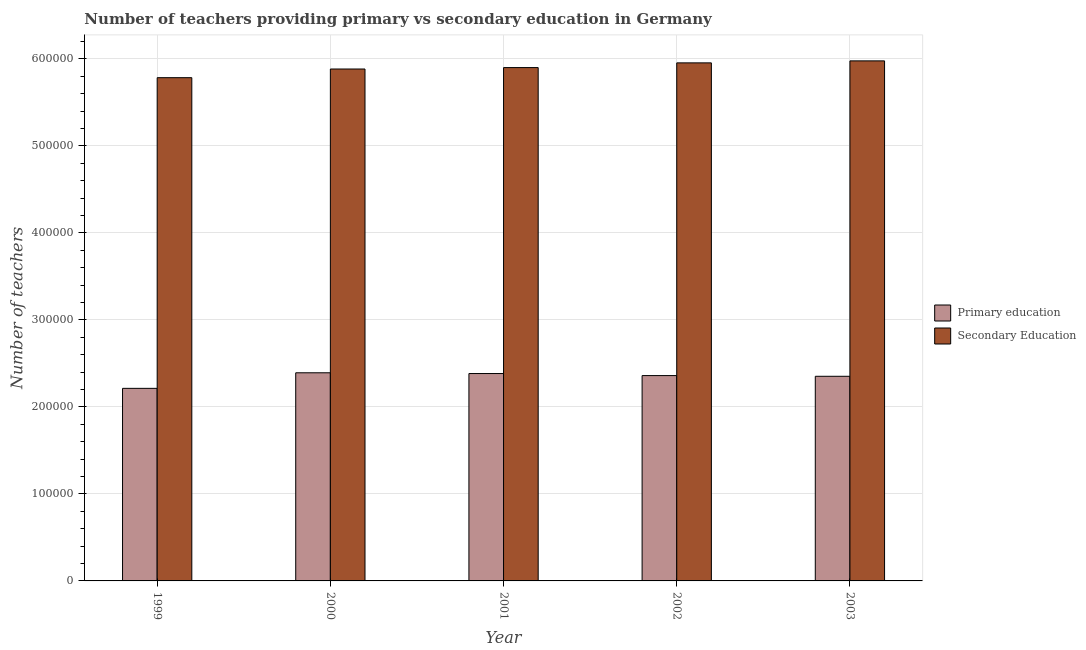How many different coloured bars are there?
Ensure brevity in your answer.  2. How many groups of bars are there?
Offer a very short reply. 5. In how many cases, is the number of bars for a given year not equal to the number of legend labels?
Make the answer very short. 0. What is the number of secondary teachers in 1999?
Make the answer very short. 5.78e+05. Across all years, what is the maximum number of primary teachers?
Ensure brevity in your answer.  2.39e+05. Across all years, what is the minimum number of secondary teachers?
Your answer should be very brief. 5.78e+05. In which year was the number of primary teachers maximum?
Ensure brevity in your answer.  2000. In which year was the number of secondary teachers minimum?
Provide a short and direct response. 1999. What is the total number of secondary teachers in the graph?
Provide a short and direct response. 2.95e+06. What is the difference between the number of secondary teachers in 1999 and that in 2001?
Provide a short and direct response. -1.16e+04. What is the difference between the number of secondary teachers in 1999 and the number of primary teachers in 2000?
Your response must be concise. -9953. What is the average number of secondary teachers per year?
Make the answer very short. 5.90e+05. In how many years, is the number of secondary teachers greater than 360000?
Keep it short and to the point. 5. What is the ratio of the number of primary teachers in 1999 to that in 2001?
Provide a succinct answer. 0.93. Is the number of primary teachers in 2000 less than that in 2001?
Provide a short and direct response. No. Is the difference between the number of secondary teachers in 1999 and 2000 greater than the difference between the number of primary teachers in 1999 and 2000?
Provide a short and direct response. No. What is the difference between the highest and the second highest number of secondary teachers?
Offer a very short reply. 2293. What is the difference between the highest and the lowest number of secondary teachers?
Your answer should be compact. 1.93e+04. Is the sum of the number of primary teachers in 1999 and 2002 greater than the maximum number of secondary teachers across all years?
Your response must be concise. Yes. What does the 2nd bar from the left in 2002 represents?
Your response must be concise. Secondary Education. How many bars are there?
Offer a very short reply. 10. How many years are there in the graph?
Make the answer very short. 5. What is the difference between two consecutive major ticks on the Y-axis?
Your response must be concise. 1.00e+05. Does the graph contain grids?
Ensure brevity in your answer.  Yes. Where does the legend appear in the graph?
Provide a succinct answer. Center right. How many legend labels are there?
Keep it short and to the point. 2. How are the legend labels stacked?
Make the answer very short. Vertical. What is the title of the graph?
Offer a terse response. Number of teachers providing primary vs secondary education in Germany. What is the label or title of the X-axis?
Your answer should be very brief. Year. What is the label or title of the Y-axis?
Your answer should be compact. Number of teachers. What is the Number of teachers in Primary education in 1999?
Your answer should be very brief. 2.21e+05. What is the Number of teachers in Secondary Education in 1999?
Ensure brevity in your answer.  5.78e+05. What is the Number of teachers of Primary education in 2000?
Ensure brevity in your answer.  2.39e+05. What is the Number of teachers of Secondary Education in 2000?
Offer a terse response. 5.88e+05. What is the Number of teachers in Primary education in 2001?
Your answer should be very brief. 2.38e+05. What is the Number of teachers of Secondary Education in 2001?
Ensure brevity in your answer.  5.90e+05. What is the Number of teachers in Primary education in 2002?
Offer a very short reply. 2.36e+05. What is the Number of teachers of Secondary Education in 2002?
Provide a short and direct response. 5.95e+05. What is the Number of teachers of Primary education in 2003?
Give a very brief answer. 2.35e+05. What is the Number of teachers of Secondary Education in 2003?
Ensure brevity in your answer.  5.98e+05. Across all years, what is the maximum Number of teachers of Primary education?
Offer a very short reply. 2.39e+05. Across all years, what is the maximum Number of teachers in Secondary Education?
Provide a succinct answer. 5.98e+05. Across all years, what is the minimum Number of teachers in Primary education?
Provide a succinct answer. 2.21e+05. Across all years, what is the minimum Number of teachers of Secondary Education?
Your answer should be very brief. 5.78e+05. What is the total Number of teachers of Primary education in the graph?
Provide a succinct answer. 1.17e+06. What is the total Number of teachers of Secondary Education in the graph?
Offer a very short reply. 2.95e+06. What is the difference between the Number of teachers of Primary education in 1999 and that in 2000?
Offer a terse response. -1.79e+04. What is the difference between the Number of teachers in Secondary Education in 1999 and that in 2000?
Your response must be concise. -9953. What is the difference between the Number of teachers of Primary education in 1999 and that in 2001?
Keep it short and to the point. -1.70e+04. What is the difference between the Number of teachers in Secondary Education in 1999 and that in 2001?
Offer a terse response. -1.16e+04. What is the difference between the Number of teachers of Primary education in 1999 and that in 2002?
Provide a succinct answer. -1.47e+04. What is the difference between the Number of teachers in Secondary Education in 1999 and that in 2002?
Keep it short and to the point. -1.70e+04. What is the difference between the Number of teachers in Primary education in 1999 and that in 2003?
Keep it short and to the point. -1.39e+04. What is the difference between the Number of teachers in Secondary Education in 1999 and that in 2003?
Provide a short and direct response. -1.93e+04. What is the difference between the Number of teachers in Primary education in 2000 and that in 2001?
Offer a terse response. 861. What is the difference between the Number of teachers of Secondary Education in 2000 and that in 2001?
Your response must be concise. -1636. What is the difference between the Number of teachers of Primary education in 2000 and that in 2002?
Provide a short and direct response. 3213. What is the difference between the Number of teachers of Secondary Education in 2000 and that in 2002?
Give a very brief answer. -7059. What is the difference between the Number of teachers in Primary education in 2000 and that in 2003?
Your response must be concise. 4027. What is the difference between the Number of teachers in Secondary Education in 2000 and that in 2003?
Provide a short and direct response. -9352. What is the difference between the Number of teachers of Primary education in 2001 and that in 2002?
Your answer should be compact. 2352. What is the difference between the Number of teachers of Secondary Education in 2001 and that in 2002?
Your answer should be very brief. -5423. What is the difference between the Number of teachers of Primary education in 2001 and that in 2003?
Your answer should be compact. 3166. What is the difference between the Number of teachers of Secondary Education in 2001 and that in 2003?
Provide a short and direct response. -7716. What is the difference between the Number of teachers of Primary education in 2002 and that in 2003?
Provide a succinct answer. 814. What is the difference between the Number of teachers in Secondary Education in 2002 and that in 2003?
Give a very brief answer. -2293. What is the difference between the Number of teachers of Primary education in 1999 and the Number of teachers of Secondary Education in 2000?
Keep it short and to the point. -3.67e+05. What is the difference between the Number of teachers of Primary education in 1999 and the Number of teachers of Secondary Education in 2001?
Provide a short and direct response. -3.69e+05. What is the difference between the Number of teachers of Primary education in 1999 and the Number of teachers of Secondary Education in 2002?
Your answer should be very brief. -3.74e+05. What is the difference between the Number of teachers of Primary education in 1999 and the Number of teachers of Secondary Education in 2003?
Provide a succinct answer. -3.76e+05. What is the difference between the Number of teachers in Primary education in 2000 and the Number of teachers in Secondary Education in 2001?
Provide a succinct answer. -3.51e+05. What is the difference between the Number of teachers in Primary education in 2000 and the Number of teachers in Secondary Education in 2002?
Provide a succinct answer. -3.56e+05. What is the difference between the Number of teachers of Primary education in 2000 and the Number of teachers of Secondary Education in 2003?
Keep it short and to the point. -3.58e+05. What is the difference between the Number of teachers in Primary education in 2001 and the Number of teachers in Secondary Education in 2002?
Provide a succinct answer. -3.57e+05. What is the difference between the Number of teachers of Primary education in 2001 and the Number of teachers of Secondary Education in 2003?
Offer a very short reply. -3.59e+05. What is the difference between the Number of teachers of Primary education in 2002 and the Number of teachers of Secondary Education in 2003?
Make the answer very short. -3.62e+05. What is the average Number of teachers in Primary education per year?
Make the answer very short. 2.34e+05. What is the average Number of teachers of Secondary Education per year?
Your response must be concise. 5.90e+05. In the year 1999, what is the difference between the Number of teachers of Primary education and Number of teachers of Secondary Education?
Your response must be concise. -3.57e+05. In the year 2000, what is the difference between the Number of teachers of Primary education and Number of teachers of Secondary Education?
Keep it short and to the point. -3.49e+05. In the year 2001, what is the difference between the Number of teachers in Primary education and Number of teachers in Secondary Education?
Offer a terse response. -3.52e+05. In the year 2002, what is the difference between the Number of teachers of Primary education and Number of teachers of Secondary Education?
Provide a short and direct response. -3.59e+05. In the year 2003, what is the difference between the Number of teachers of Primary education and Number of teachers of Secondary Education?
Offer a terse response. -3.63e+05. What is the ratio of the Number of teachers in Primary education in 1999 to that in 2000?
Offer a very short reply. 0.93. What is the ratio of the Number of teachers in Secondary Education in 1999 to that in 2000?
Provide a short and direct response. 0.98. What is the ratio of the Number of teachers of Secondary Education in 1999 to that in 2001?
Your answer should be very brief. 0.98. What is the ratio of the Number of teachers in Primary education in 1999 to that in 2002?
Keep it short and to the point. 0.94. What is the ratio of the Number of teachers of Secondary Education in 1999 to that in 2002?
Your response must be concise. 0.97. What is the ratio of the Number of teachers of Primary education in 1999 to that in 2003?
Give a very brief answer. 0.94. What is the ratio of the Number of teachers in Secondary Education in 1999 to that in 2003?
Your answer should be very brief. 0.97. What is the ratio of the Number of teachers in Secondary Education in 2000 to that in 2001?
Provide a succinct answer. 1. What is the ratio of the Number of teachers of Primary education in 2000 to that in 2002?
Your answer should be very brief. 1.01. What is the ratio of the Number of teachers of Secondary Education in 2000 to that in 2002?
Offer a very short reply. 0.99. What is the ratio of the Number of teachers of Primary education in 2000 to that in 2003?
Your answer should be compact. 1.02. What is the ratio of the Number of teachers in Secondary Education in 2000 to that in 2003?
Offer a very short reply. 0.98. What is the ratio of the Number of teachers in Primary education in 2001 to that in 2002?
Offer a very short reply. 1.01. What is the ratio of the Number of teachers in Secondary Education in 2001 to that in 2002?
Provide a succinct answer. 0.99. What is the ratio of the Number of teachers of Primary education in 2001 to that in 2003?
Provide a short and direct response. 1.01. What is the ratio of the Number of teachers in Secondary Education in 2001 to that in 2003?
Your answer should be very brief. 0.99. What is the ratio of the Number of teachers of Primary education in 2002 to that in 2003?
Offer a very short reply. 1. What is the difference between the highest and the second highest Number of teachers in Primary education?
Ensure brevity in your answer.  861. What is the difference between the highest and the second highest Number of teachers in Secondary Education?
Give a very brief answer. 2293. What is the difference between the highest and the lowest Number of teachers in Primary education?
Offer a terse response. 1.79e+04. What is the difference between the highest and the lowest Number of teachers of Secondary Education?
Make the answer very short. 1.93e+04. 